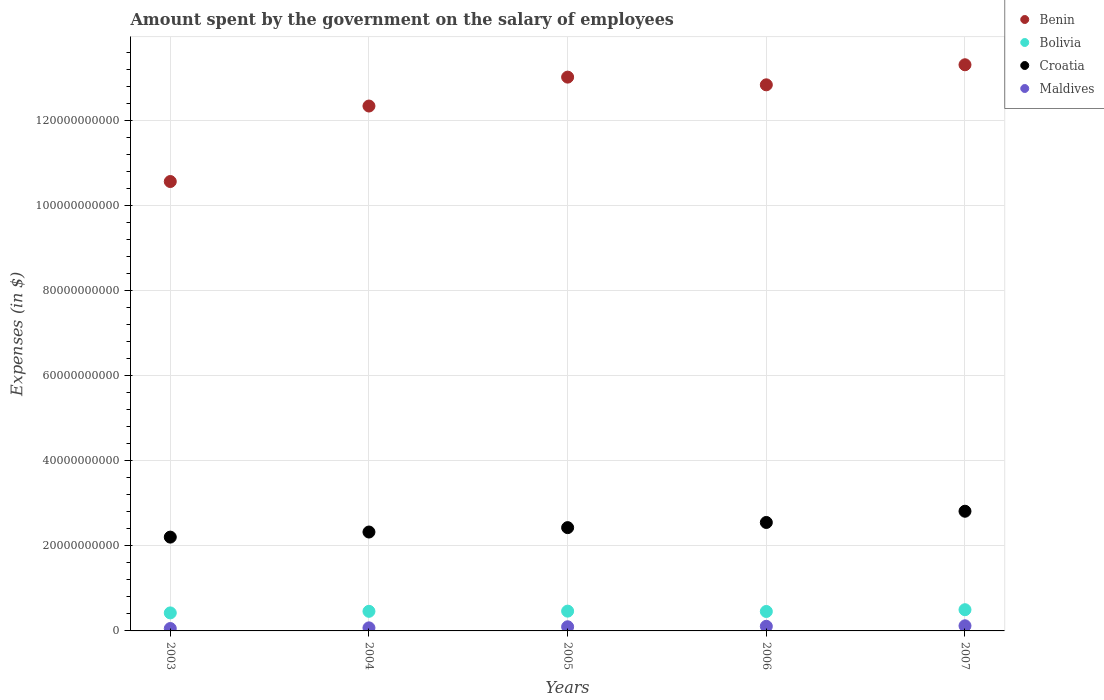Is the number of dotlines equal to the number of legend labels?
Keep it short and to the point. Yes. What is the amount spent on the salary of employees by the government in Croatia in 2003?
Provide a succinct answer. 2.21e+1. Across all years, what is the maximum amount spent on the salary of employees by the government in Bolivia?
Keep it short and to the point. 4.99e+09. Across all years, what is the minimum amount spent on the salary of employees by the government in Bolivia?
Provide a short and direct response. 4.24e+09. In which year was the amount spent on the salary of employees by the government in Bolivia maximum?
Your answer should be very brief. 2007. What is the total amount spent on the salary of employees by the government in Benin in the graph?
Your answer should be very brief. 6.21e+11. What is the difference between the amount spent on the salary of employees by the government in Benin in 2005 and that in 2006?
Ensure brevity in your answer.  1.81e+09. What is the difference between the amount spent on the salary of employees by the government in Croatia in 2003 and the amount spent on the salary of employees by the government in Benin in 2005?
Ensure brevity in your answer.  -1.08e+11. What is the average amount spent on the salary of employees by the government in Bolivia per year?
Your answer should be very brief. 4.61e+09. In the year 2007, what is the difference between the amount spent on the salary of employees by the government in Bolivia and amount spent on the salary of employees by the government in Maldives?
Provide a short and direct response. 3.78e+09. What is the ratio of the amount spent on the salary of employees by the government in Croatia in 2003 to that in 2007?
Keep it short and to the point. 0.78. Is the difference between the amount spent on the salary of employees by the government in Bolivia in 2004 and 2007 greater than the difference between the amount spent on the salary of employees by the government in Maldives in 2004 and 2007?
Keep it short and to the point. Yes. What is the difference between the highest and the second highest amount spent on the salary of employees by the government in Bolivia?
Give a very brief answer. 3.37e+08. What is the difference between the highest and the lowest amount spent on the salary of employees by the government in Benin?
Your response must be concise. 2.75e+1. In how many years, is the amount spent on the salary of employees by the government in Croatia greater than the average amount spent on the salary of employees by the government in Croatia taken over all years?
Keep it short and to the point. 2. Is it the case that in every year, the sum of the amount spent on the salary of employees by the government in Bolivia and amount spent on the salary of employees by the government in Benin  is greater than the amount spent on the salary of employees by the government in Maldives?
Keep it short and to the point. Yes. Does the amount spent on the salary of employees by the government in Benin monotonically increase over the years?
Offer a very short reply. No. Is the amount spent on the salary of employees by the government in Maldives strictly less than the amount spent on the salary of employees by the government in Croatia over the years?
Your answer should be compact. Yes. What is the difference between two consecutive major ticks on the Y-axis?
Your answer should be very brief. 2.00e+1. How many legend labels are there?
Give a very brief answer. 4. How are the legend labels stacked?
Your response must be concise. Vertical. What is the title of the graph?
Provide a succinct answer. Amount spent by the government on the salary of employees. What is the label or title of the Y-axis?
Offer a very short reply. Expenses (in $). What is the Expenses (in $) of Benin in 2003?
Your answer should be very brief. 1.06e+11. What is the Expenses (in $) of Bolivia in 2003?
Keep it short and to the point. 4.24e+09. What is the Expenses (in $) of Croatia in 2003?
Your response must be concise. 2.21e+1. What is the Expenses (in $) of Maldives in 2003?
Ensure brevity in your answer.  5.64e+08. What is the Expenses (in $) in Benin in 2004?
Provide a short and direct response. 1.23e+11. What is the Expenses (in $) in Bolivia in 2004?
Provide a short and direct response. 4.61e+09. What is the Expenses (in $) of Croatia in 2004?
Ensure brevity in your answer.  2.33e+1. What is the Expenses (in $) in Maldives in 2004?
Give a very brief answer. 7.19e+08. What is the Expenses (in $) in Benin in 2005?
Ensure brevity in your answer.  1.30e+11. What is the Expenses (in $) of Bolivia in 2005?
Give a very brief answer. 4.65e+09. What is the Expenses (in $) in Croatia in 2005?
Your answer should be compact. 2.43e+1. What is the Expenses (in $) of Maldives in 2005?
Give a very brief answer. 9.74e+08. What is the Expenses (in $) in Benin in 2006?
Give a very brief answer. 1.28e+11. What is the Expenses (in $) in Bolivia in 2006?
Provide a short and direct response. 4.57e+09. What is the Expenses (in $) of Croatia in 2006?
Offer a very short reply. 2.55e+1. What is the Expenses (in $) in Maldives in 2006?
Your answer should be compact. 1.09e+09. What is the Expenses (in $) in Benin in 2007?
Keep it short and to the point. 1.33e+11. What is the Expenses (in $) in Bolivia in 2007?
Provide a short and direct response. 4.99e+09. What is the Expenses (in $) of Croatia in 2007?
Your answer should be compact. 2.82e+1. What is the Expenses (in $) in Maldives in 2007?
Provide a succinct answer. 1.21e+09. Across all years, what is the maximum Expenses (in $) of Benin?
Offer a terse response. 1.33e+11. Across all years, what is the maximum Expenses (in $) of Bolivia?
Your answer should be compact. 4.99e+09. Across all years, what is the maximum Expenses (in $) of Croatia?
Make the answer very short. 2.82e+1. Across all years, what is the maximum Expenses (in $) of Maldives?
Provide a succinct answer. 1.21e+09. Across all years, what is the minimum Expenses (in $) of Benin?
Provide a succinct answer. 1.06e+11. Across all years, what is the minimum Expenses (in $) of Bolivia?
Your response must be concise. 4.24e+09. Across all years, what is the minimum Expenses (in $) of Croatia?
Ensure brevity in your answer.  2.21e+1. Across all years, what is the minimum Expenses (in $) of Maldives?
Offer a very short reply. 5.64e+08. What is the total Expenses (in $) of Benin in the graph?
Your answer should be compact. 6.21e+11. What is the total Expenses (in $) in Bolivia in the graph?
Keep it short and to the point. 2.31e+1. What is the total Expenses (in $) in Croatia in the graph?
Make the answer very short. 1.23e+11. What is the total Expenses (in $) of Maldives in the graph?
Ensure brevity in your answer.  4.55e+09. What is the difference between the Expenses (in $) in Benin in 2003 and that in 2004?
Keep it short and to the point. -1.78e+1. What is the difference between the Expenses (in $) in Bolivia in 2003 and that in 2004?
Provide a succinct answer. -3.74e+08. What is the difference between the Expenses (in $) of Croatia in 2003 and that in 2004?
Give a very brief answer. -1.20e+09. What is the difference between the Expenses (in $) in Maldives in 2003 and that in 2004?
Provide a succinct answer. -1.55e+08. What is the difference between the Expenses (in $) of Benin in 2003 and that in 2005?
Give a very brief answer. -2.46e+1. What is the difference between the Expenses (in $) of Bolivia in 2003 and that in 2005?
Make the answer very short. -4.16e+08. What is the difference between the Expenses (in $) of Croatia in 2003 and that in 2005?
Your response must be concise. -2.23e+09. What is the difference between the Expenses (in $) of Maldives in 2003 and that in 2005?
Ensure brevity in your answer.  -4.10e+08. What is the difference between the Expenses (in $) of Benin in 2003 and that in 2006?
Offer a very short reply. -2.27e+1. What is the difference between the Expenses (in $) in Bolivia in 2003 and that in 2006?
Offer a terse response. -3.37e+08. What is the difference between the Expenses (in $) in Croatia in 2003 and that in 2006?
Your answer should be very brief. -3.44e+09. What is the difference between the Expenses (in $) of Maldives in 2003 and that in 2006?
Offer a very short reply. -5.21e+08. What is the difference between the Expenses (in $) in Benin in 2003 and that in 2007?
Your answer should be compact. -2.75e+1. What is the difference between the Expenses (in $) in Bolivia in 2003 and that in 2007?
Ensure brevity in your answer.  -7.53e+08. What is the difference between the Expenses (in $) in Croatia in 2003 and that in 2007?
Keep it short and to the point. -6.09e+09. What is the difference between the Expenses (in $) in Maldives in 2003 and that in 2007?
Give a very brief answer. -6.44e+08. What is the difference between the Expenses (in $) in Benin in 2004 and that in 2005?
Provide a succinct answer. -6.80e+09. What is the difference between the Expenses (in $) of Bolivia in 2004 and that in 2005?
Your answer should be compact. -4.21e+07. What is the difference between the Expenses (in $) of Croatia in 2004 and that in 2005?
Provide a succinct answer. -1.03e+09. What is the difference between the Expenses (in $) in Maldives in 2004 and that in 2005?
Keep it short and to the point. -2.56e+08. What is the difference between the Expenses (in $) in Benin in 2004 and that in 2006?
Give a very brief answer. -4.99e+09. What is the difference between the Expenses (in $) in Bolivia in 2004 and that in 2006?
Your answer should be very brief. 3.71e+07. What is the difference between the Expenses (in $) of Croatia in 2004 and that in 2006?
Keep it short and to the point. -2.25e+09. What is the difference between the Expenses (in $) of Maldives in 2004 and that in 2006?
Your answer should be compact. -3.66e+08. What is the difference between the Expenses (in $) of Benin in 2004 and that in 2007?
Your answer should be very brief. -9.71e+09. What is the difference between the Expenses (in $) of Bolivia in 2004 and that in 2007?
Make the answer very short. -3.79e+08. What is the difference between the Expenses (in $) in Croatia in 2004 and that in 2007?
Your answer should be compact. -4.89e+09. What is the difference between the Expenses (in $) in Maldives in 2004 and that in 2007?
Ensure brevity in your answer.  -4.90e+08. What is the difference between the Expenses (in $) of Benin in 2005 and that in 2006?
Your answer should be compact. 1.81e+09. What is the difference between the Expenses (in $) in Bolivia in 2005 and that in 2006?
Provide a short and direct response. 7.92e+07. What is the difference between the Expenses (in $) in Croatia in 2005 and that in 2006?
Offer a very short reply. -1.21e+09. What is the difference between the Expenses (in $) in Maldives in 2005 and that in 2006?
Offer a terse response. -1.11e+08. What is the difference between the Expenses (in $) of Benin in 2005 and that in 2007?
Your answer should be very brief. -2.91e+09. What is the difference between the Expenses (in $) in Bolivia in 2005 and that in 2007?
Your answer should be compact. -3.37e+08. What is the difference between the Expenses (in $) of Croatia in 2005 and that in 2007?
Offer a very short reply. -3.85e+09. What is the difference between the Expenses (in $) of Maldives in 2005 and that in 2007?
Your answer should be very brief. -2.34e+08. What is the difference between the Expenses (in $) of Benin in 2006 and that in 2007?
Offer a terse response. -4.72e+09. What is the difference between the Expenses (in $) of Bolivia in 2006 and that in 2007?
Your response must be concise. -4.16e+08. What is the difference between the Expenses (in $) in Croatia in 2006 and that in 2007?
Ensure brevity in your answer.  -2.64e+09. What is the difference between the Expenses (in $) of Maldives in 2006 and that in 2007?
Make the answer very short. -1.23e+08. What is the difference between the Expenses (in $) of Benin in 2003 and the Expenses (in $) of Bolivia in 2004?
Provide a short and direct response. 1.01e+11. What is the difference between the Expenses (in $) in Benin in 2003 and the Expenses (in $) in Croatia in 2004?
Your response must be concise. 8.25e+1. What is the difference between the Expenses (in $) of Benin in 2003 and the Expenses (in $) of Maldives in 2004?
Your answer should be very brief. 1.05e+11. What is the difference between the Expenses (in $) in Bolivia in 2003 and the Expenses (in $) in Croatia in 2004?
Give a very brief answer. -1.90e+1. What is the difference between the Expenses (in $) in Bolivia in 2003 and the Expenses (in $) in Maldives in 2004?
Give a very brief answer. 3.52e+09. What is the difference between the Expenses (in $) of Croatia in 2003 and the Expenses (in $) of Maldives in 2004?
Your answer should be compact. 2.13e+1. What is the difference between the Expenses (in $) in Benin in 2003 and the Expenses (in $) in Bolivia in 2005?
Provide a succinct answer. 1.01e+11. What is the difference between the Expenses (in $) in Benin in 2003 and the Expenses (in $) in Croatia in 2005?
Your response must be concise. 8.14e+1. What is the difference between the Expenses (in $) of Benin in 2003 and the Expenses (in $) of Maldives in 2005?
Make the answer very short. 1.05e+11. What is the difference between the Expenses (in $) of Bolivia in 2003 and the Expenses (in $) of Croatia in 2005?
Your answer should be very brief. -2.01e+1. What is the difference between the Expenses (in $) of Bolivia in 2003 and the Expenses (in $) of Maldives in 2005?
Provide a succinct answer. 3.26e+09. What is the difference between the Expenses (in $) of Croatia in 2003 and the Expenses (in $) of Maldives in 2005?
Your answer should be compact. 2.11e+1. What is the difference between the Expenses (in $) in Benin in 2003 and the Expenses (in $) in Bolivia in 2006?
Your response must be concise. 1.01e+11. What is the difference between the Expenses (in $) of Benin in 2003 and the Expenses (in $) of Croatia in 2006?
Provide a short and direct response. 8.02e+1. What is the difference between the Expenses (in $) of Benin in 2003 and the Expenses (in $) of Maldives in 2006?
Your answer should be very brief. 1.05e+11. What is the difference between the Expenses (in $) in Bolivia in 2003 and the Expenses (in $) in Croatia in 2006?
Your response must be concise. -2.13e+1. What is the difference between the Expenses (in $) in Bolivia in 2003 and the Expenses (in $) in Maldives in 2006?
Your answer should be compact. 3.15e+09. What is the difference between the Expenses (in $) in Croatia in 2003 and the Expenses (in $) in Maldives in 2006?
Make the answer very short. 2.10e+1. What is the difference between the Expenses (in $) of Benin in 2003 and the Expenses (in $) of Bolivia in 2007?
Your response must be concise. 1.01e+11. What is the difference between the Expenses (in $) in Benin in 2003 and the Expenses (in $) in Croatia in 2007?
Your answer should be very brief. 7.76e+1. What is the difference between the Expenses (in $) of Benin in 2003 and the Expenses (in $) of Maldives in 2007?
Provide a succinct answer. 1.05e+11. What is the difference between the Expenses (in $) of Bolivia in 2003 and the Expenses (in $) of Croatia in 2007?
Give a very brief answer. -2.39e+1. What is the difference between the Expenses (in $) in Bolivia in 2003 and the Expenses (in $) in Maldives in 2007?
Your answer should be very brief. 3.03e+09. What is the difference between the Expenses (in $) in Croatia in 2003 and the Expenses (in $) in Maldives in 2007?
Provide a short and direct response. 2.09e+1. What is the difference between the Expenses (in $) of Benin in 2004 and the Expenses (in $) of Bolivia in 2005?
Your response must be concise. 1.19e+11. What is the difference between the Expenses (in $) of Benin in 2004 and the Expenses (in $) of Croatia in 2005?
Your answer should be compact. 9.92e+1. What is the difference between the Expenses (in $) in Benin in 2004 and the Expenses (in $) in Maldives in 2005?
Keep it short and to the point. 1.23e+11. What is the difference between the Expenses (in $) in Bolivia in 2004 and the Expenses (in $) in Croatia in 2005?
Make the answer very short. -1.97e+1. What is the difference between the Expenses (in $) of Bolivia in 2004 and the Expenses (in $) of Maldives in 2005?
Keep it short and to the point. 3.64e+09. What is the difference between the Expenses (in $) of Croatia in 2004 and the Expenses (in $) of Maldives in 2005?
Your answer should be very brief. 2.23e+1. What is the difference between the Expenses (in $) of Benin in 2004 and the Expenses (in $) of Bolivia in 2006?
Ensure brevity in your answer.  1.19e+11. What is the difference between the Expenses (in $) in Benin in 2004 and the Expenses (in $) in Croatia in 2006?
Offer a very short reply. 9.80e+1. What is the difference between the Expenses (in $) of Benin in 2004 and the Expenses (in $) of Maldives in 2006?
Make the answer very short. 1.22e+11. What is the difference between the Expenses (in $) in Bolivia in 2004 and the Expenses (in $) in Croatia in 2006?
Make the answer very short. -2.09e+1. What is the difference between the Expenses (in $) in Bolivia in 2004 and the Expenses (in $) in Maldives in 2006?
Keep it short and to the point. 3.53e+09. What is the difference between the Expenses (in $) in Croatia in 2004 and the Expenses (in $) in Maldives in 2006?
Offer a very short reply. 2.22e+1. What is the difference between the Expenses (in $) of Benin in 2004 and the Expenses (in $) of Bolivia in 2007?
Offer a terse response. 1.18e+11. What is the difference between the Expenses (in $) of Benin in 2004 and the Expenses (in $) of Croatia in 2007?
Your response must be concise. 9.53e+1. What is the difference between the Expenses (in $) of Benin in 2004 and the Expenses (in $) of Maldives in 2007?
Provide a succinct answer. 1.22e+11. What is the difference between the Expenses (in $) in Bolivia in 2004 and the Expenses (in $) in Croatia in 2007?
Provide a short and direct response. -2.35e+1. What is the difference between the Expenses (in $) in Bolivia in 2004 and the Expenses (in $) in Maldives in 2007?
Give a very brief answer. 3.40e+09. What is the difference between the Expenses (in $) in Croatia in 2004 and the Expenses (in $) in Maldives in 2007?
Offer a very short reply. 2.21e+1. What is the difference between the Expenses (in $) in Benin in 2005 and the Expenses (in $) in Bolivia in 2006?
Offer a very short reply. 1.26e+11. What is the difference between the Expenses (in $) in Benin in 2005 and the Expenses (in $) in Croatia in 2006?
Your answer should be compact. 1.05e+11. What is the difference between the Expenses (in $) of Benin in 2005 and the Expenses (in $) of Maldives in 2006?
Make the answer very short. 1.29e+11. What is the difference between the Expenses (in $) in Bolivia in 2005 and the Expenses (in $) in Croatia in 2006?
Your answer should be compact. -2.09e+1. What is the difference between the Expenses (in $) in Bolivia in 2005 and the Expenses (in $) in Maldives in 2006?
Keep it short and to the point. 3.57e+09. What is the difference between the Expenses (in $) of Croatia in 2005 and the Expenses (in $) of Maldives in 2006?
Your answer should be very brief. 2.32e+1. What is the difference between the Expenses (in $) in Benin in 2005 and the Expenses (in $) in Bolivia in 2007?
Ensure brevity in your answer.  1.25e+11. What is the difference between the Expenses (in $) in Benin in 2005 and the Expenses (in $) in Croatia in 2007?
Your answer should be very brief. 1.02e+11. What is the difference between the Expenses (in $) in Benin in 2005 and the Expenses (in $) in Maldives in 2007?
Keep it short and to the point. 1.29e+11. What is the difference between the Expenses (in $) in Bolivia in 2005 and the Expenses (in $) in Croatia in 2007?
Your answer should be very brief. -2.35e+1. What is the difference between the Expenses (in $) of Bolivia in 2005 and the Expenses (in $) of Maldives in 2007?
Your answer should be compact. 3.45e+09. What is the difference between the Expenses (in $) in Croatia in 2005 and the Expenses (in $) in Maldives in 2007?
Your answer should be compact. 2.31e+1. What is the difference between the Expenses (in $) of Benin in 2006 and the Expenses (in $) of Bolivia in 2007?
Your answer should be compact. 1.23e+11. What is the difference between the Expenses (in $) of Benin in 2006 and the Expenses (in $) of Croatia in 2007?
Your answer should be very brief. 1.00e+11. What is the difference between the Expenses (in $) in Benin in 2006 and the Expenses (in $) in Maldives in 2007?
Your answer should be compact. 1.27e+11. What is the difference between the Expenses (in $) in Bolivia in 2006 and the Expenses (in $) in Croatia in 2007?
Provide a succinct answer. -2.36e+1. What is the difference between the Expenses (in $) in Bolivia in 2006 and the Expenses (in $) in Maldives in 2007?
Provide a succinct answer. 3.37e+09. What is the difference between the Expenses (in $) of Croatia in 2006 and the Expenses (in $) of Maldives in 2007?
Your response must be concise. 2.43e+1. What is the average Expenses (in $) in Benin per year?
Your answer should be very brief. 1.24e+11. What is the average Expenses (in $) of Bolivia per year?
Keep it short and to the point. 4.61e+09. What is the average Expenses (in $) in Croatia per year?
Ensure brevity in your answer.  2.47e+1. What is the average Expenses (in $) of Maldives per year?
Your answer should be very brief. 9.10e+08. In the year 2003, what is the difference between the Expenses (in $) in Benin and Expenses (in $) in Bolivia?
Offer a terse response. 1.01e+11. In the year 2003, what is the difference between the Expenses (in $) in Benin and Expenses (in $) in Croatia?
Keep it short and to the point. 8.37e+1. In the year 2003, what is the difference between the Expenses (in $) in Benin and Expenses (in $) in Maldives?
Your answer should be compact. 1.05e+11. In the year 2003, what is the difference between the Expenses (in $) of Bolivia and Expenses (in $) of Croatia?
Offer a very short reply. -1.78e+1. In the year 2003, what is the difference between the Expenses (in $) of Bolivia and Expenses (in $) of Maldives?
Ensure brevity in your answer.  3.67e+09. In the year 2003, what is the difference between the Expenses (in $) of Croatia and Expenses (in $) of Maldives?
Your answer should be very brief. 2.15e+1. In the year 2004, what is the difference between the Expenses (in $) of Benin and Expenses (in $) of Bolivia?
Keep it short and to the point. 1.19e+11. In the year 2004, what is the difference between the Expenses (in $) in Benin and Expenses (in $) in Croatia?
Your answer should be very brief. 1.00e+11. In the year 2004, what is the difference between the Expenses (in $) of Benin and Expenses (in $) of Maldives?
Offer a very short reply. 1.23e+11. In the year 2004, what is the difference between the Expenses (in $) in Bolivia and Expenses (in $) in Croatia?
Your answer should be compact. -1.87e+1. In the year 2004, what is the difference between the Expenses (in $) in Bolivia and Expenses (in $) in Maldives?
Your answer should be very brief. 3.89e+09. In the year 2004, what is the difference between the Expenses (in $) in Croatia and Expenses (in $) in Maldives?
Give a very brief answer. 2.25e+1. In the year 2005, what is the difference between the Expenses (in $) of Benin and Expenses (in $) of Bolivia?
Offer a terse response. 1.26e+11. In the year 2005, what is the difference between the Expenses (in $) in Benin and Expenses (in $) in Croatia?
Offer a terse response. 1.06e+11. In the year 2005, what is the difference between the Expenses (in $) in Benin and Expenses (in $) in Maldives?
Ensure brevity in your answer.  1.29e+11. In the year 2005, what is the difference between the Expenses (in $) of Bolivia and Expenses (in $) of Croatia?
Your answer should be compact. -1.96e+1. In the year 2005, what is the difference between the Expenses (in $) in Bolivia and Expenses (in $) in Maldives?
Provide a succinct answer. 3.68e+09. In the year 2005, what is the difference between the Expenses (in $) of Croatia and Expenses (in $) of Maldives?
Make the answer very short. 2.33e+1. In the year 2006, what is the difference between the Expenses (in $) in Benin and Expenses (in $) in Bolivia?
Your response must be concise. 1.24e+11. In the year 2006, what is the difference between the Expenses (in $) in Benin and Expenses (in $) in Croatia?
Give a very brief answer. 1.03e+11. In the year 2006, what is the difference between the Expenses (in $) of Benin and Expenses (in $) of Maldives?
Your answer should be very brief. 1.27e+11. In the year 2006, what is the difference between the Expenses (in $) of Bolivia and Expenses (in $) of Croatia?
Provide a short and direct response. -2.09e+1. In the year 2006, what is the difference between the Expenses (in $) in Bolivia and Expenses (in $) in Maldives?
Your response must be concise. 3.49e+09. In the year 2006, what is the difference between the Expenses (in $) of Croatia and Expenses (in $) of Maldives?
Give a very brief answer. 2.44e+1. In the year 2007, what is the difference between the Expenses (in $) in Benin and Expenses (in $) in Bolivia?
Your response must be concise. 1.28e+11. In the year 2007, what is the difference between the Expenses (in $) in Benin and Expenses (in $) in Croatia?
Ensure brevity in your answer.  1.05e+11. In the year 2007, what is the difference between the Expenses (in $) of Benin and Expenses (in $) of Maldives?
Give a very brief answer. 1.32e+11. In the year 2007, what is the difference between the Expenses (in $) in Bolivia and Expenses (in $) in Croatia?
Offer a very short reply. -2.32e+1. In the year 2007, what is the difference between the Expenses (in $) in Bolivia and Expenses (in $) in Maldives?
Keep it short and to the point. 3.78e+09. In the year 2007, what is the difference between the Expenses (in $) of Croatia and Expenses (in $) of Maldives?
Offer a very short reply. 2.69e+1. What is the ratio of the Expenses (in $) in Benin in 2003 to that in 2004?
Make the answer very short. 0.86. What is the ratio of the Expenses (in $) of Bolivia in 2003 to that in 2004?
Keep it short and to the point. 0.92. What is the ratio of the Expenses (in $) in Croatia in 2003 to that in 2004?
Provide a short and direct response. 0.95. What is the ratio of the Expenses (in $) of Maldives in 2003 to that in 2004?
Offer a terse response. 0.78. What is the ratio of the Expenses (in $) in Benin in 2003 to that in 2005?
Make the answer very short. 0.81. What is the ratio of the Expenses (in $) of Bolivia in 2003 to that in 2005?
Keep it short and to the point. 0.91. What is the ratio of the Expenses (in $) in Croatia in 2003 to that in 2005?
Offer a terse response. 0.91. What is the ratio of the Expenses (in $) of Maldives in 2003 to that in 2005?
Ensure brevity in your answer.  0.58. What is the ratio of the Expenses (in $) in Benin in 2003 to that in 2006?
Your answer should be very brief. 0.82. What is the ratio of the Expenses (in $) in Bolivia in 2003 to that in 2006?
Your response must be concise. 0.93. What is the ratio of the Expenses (in $) of Croatia in 2003 to that in 2006?
Your answer should be compact. 0.86. What is the ratio of the Expenses (in $) in Maldives in 2003 to that in 2006?
Your answer should be compact. 0.52. What is the ratio of the Expenses (in $) in Benin in 2003 to that in 2007?
Provide a short and direct response. 0.79. What is the ratio of the Expenses (in $) of Bolivia in 2003 to that in 2007?
Your response must be concise. 0.85. What is the ratio of the Expenses (in $) of Croatia in 2003 to that in 2007?
Provide a succinct answer. 0.78. What is the ratio of the Expenses (in $) of Maldives in 2003 to that in 2007?
Provide a short and direct response. 0.47. What is the ratio of the Expenses (in $) of Benin in 2004 to that in 2005?
Your response must be concise. 0.95. What is the ratio of the Expenses (in $) in Croatia in 2004 to that in 2005?
Provide a succinct answer. 0.96. What is the ratio of the Expenses (in $) of Maldives in 2004 to that in 2005?
Your answer should be compact. 0.74. What is the ratio of the Expenses (in $) of Benin in 2004 to that in 2006?
Make the answer very short. 0.96. What is the ratio of the Expenses (in $) in Croatia in 2004 to that in 2006?
Provide a short and direct response. 0.91. What is the ratio of the Expenses (in $) of Maldives in 2004 to that in 2006?
Your answer should be very brief. 0.66. What is the ratio of the Expenses (in $) of Benin in 2004 to that in 2007?
Your answer should be compact. 0.93. What is the ratio of the Expenses (in $) in Bolivia in 2004 to that in 2007?
Offer a terse response. 0.92. What is the ratio of the Expenses (in $) in Croatia in 2004 to that in 2007?
Your response must be concise. 0.83. What is the ratio of the Expenses (in $) in Maldives in 2004 to that in 2007?
Your answer should be very brief. 0.59. What is the ratio of the Expenses (in $) in Benin in 2005 to that in 2006?
Your answer should be very brief. 1.01. What is the ratio of the Expenses (in $) of Bolivia in 2005 to that in 2006?
Your response must be concise. 1.02. What is the ratio of the Expenses (in $) in Croatia in 2005 to that in 2006?
Your response must be concise. 0.95. What is the ratio of the Expenses (in $) of Maldives in 2005 to that in 2006?
Ensure brevity in your answer.  0.9. What is the ratio of the Expenses (in $) of Benin in 2005 to that in 2007?
Offer a terse response. 0.98. What is the ratio of the Expenses (in $) of Bolivia in 2005 to that in 2007?
Your answer should be compact. 0.93. What is the ratio of the Expenses (in $) in Croatia in 2005 to that in 2007?
Your answer should be compact. 0.86. What is the ratio of the Expenses (in $) in Maldives in 2005 to that in 2007?
Your answer should be compact. 0.81. What is the ratio of the Expenses (in $) of Benin in 2006 to that in 2007?
Provide a succinct answer. 0.96. What is the ratio of the Expenses (in $) of Bolivia in 2006 to that in 2007?
Ensure brevity in your answer.  0.92. What is the ratio of the Expenses (in $) of Croatia in 2006 to that in 2007?
Keep it short and to the point. 0.91. What is the ratio of the Expenses (in $) of Maldives in 2006 to that in 2007?
Make the answer very short. 0.9. What is the difference between the highest and the second highest Expenses (in $) of Benin?
Give a very brief answer. 2.91e+09. What is the difference between the highest and the second highest Expenses (in $) in Bolivia?
Ensure brevity in your answer.  3.37e+08. What is the difference between the highest and the second highest Expenses (in $) in Croatia?
Make the answer very short. 2.64e+09. What is the difference between the highest and the second highest Expenses (in $) of Maldives?
Provide a short and direct response. 1.23e+08. What is the difference between the highest and the lowest Expenses (in $) of Benin?
Offer a very short reply. 2.75e+1. What is the difference between the highest and the lowest Expenses (in $) in Bolivia?
Give a very brief answer. 7.53e+08. What is the difference between the highest and the lowest Expenses (in $) in Croatia?
Keep it short and to the point. 6.09e+09. What is the difference between the highest and the lowest Expenses (in $) of Maldives?
Your answer should be compact. 6.44e+08. 